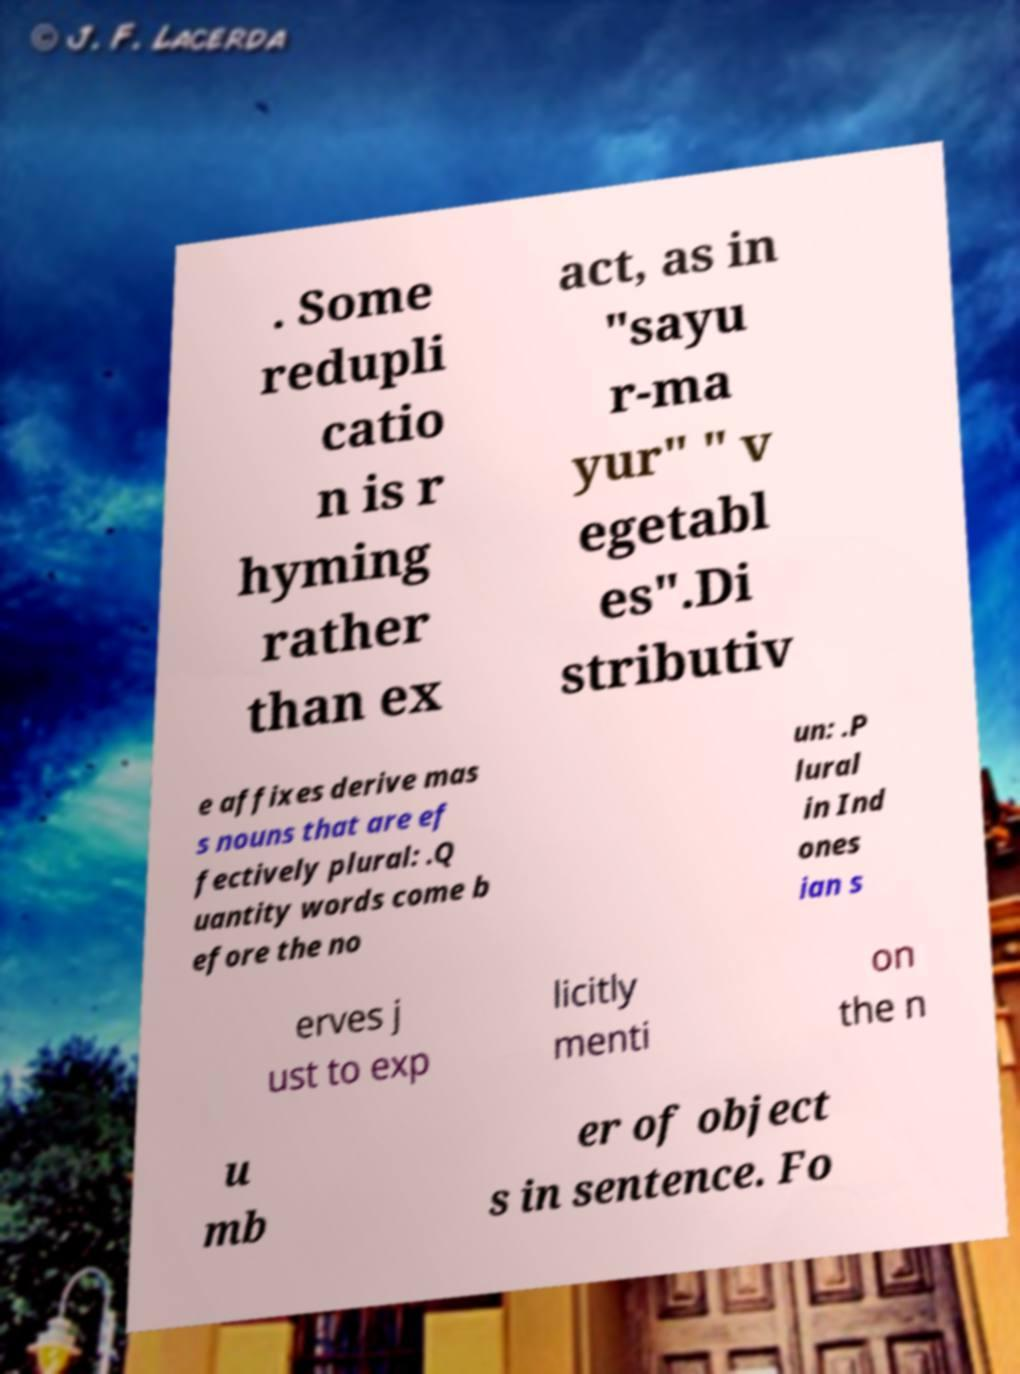Can you read and provide the text displayed in the image?This photo seems to have some interesting text. Can you extract and type it out for me? . Some redupli catio n is r hyming rather than ex act, as in "sayu r-ma yur" " v egetabl es".Di stributiv e affixes derive mas s nouns that are ef fectively plural: .Q uantity words come b efore the no un: .P lural in Ind ones ian s erves j ust to exp licitly menti on the n u mb er of object s in sentence. Fo 